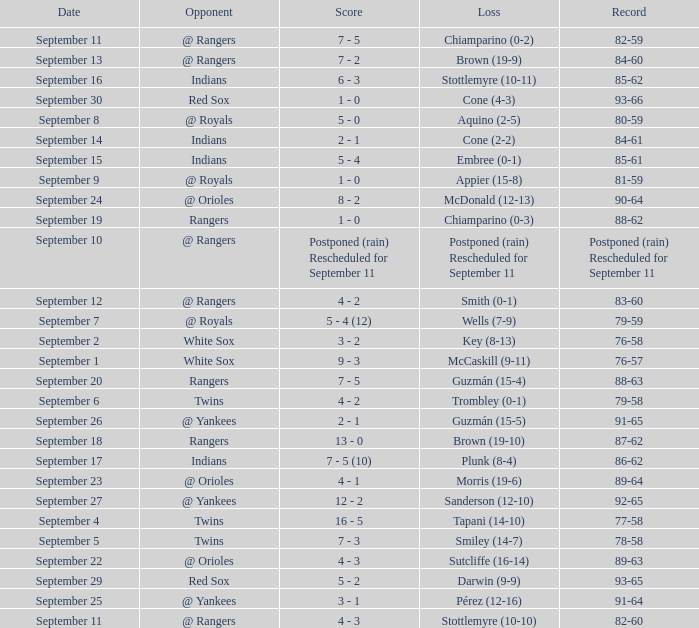What opponent has a record of 86-62? Indians. 